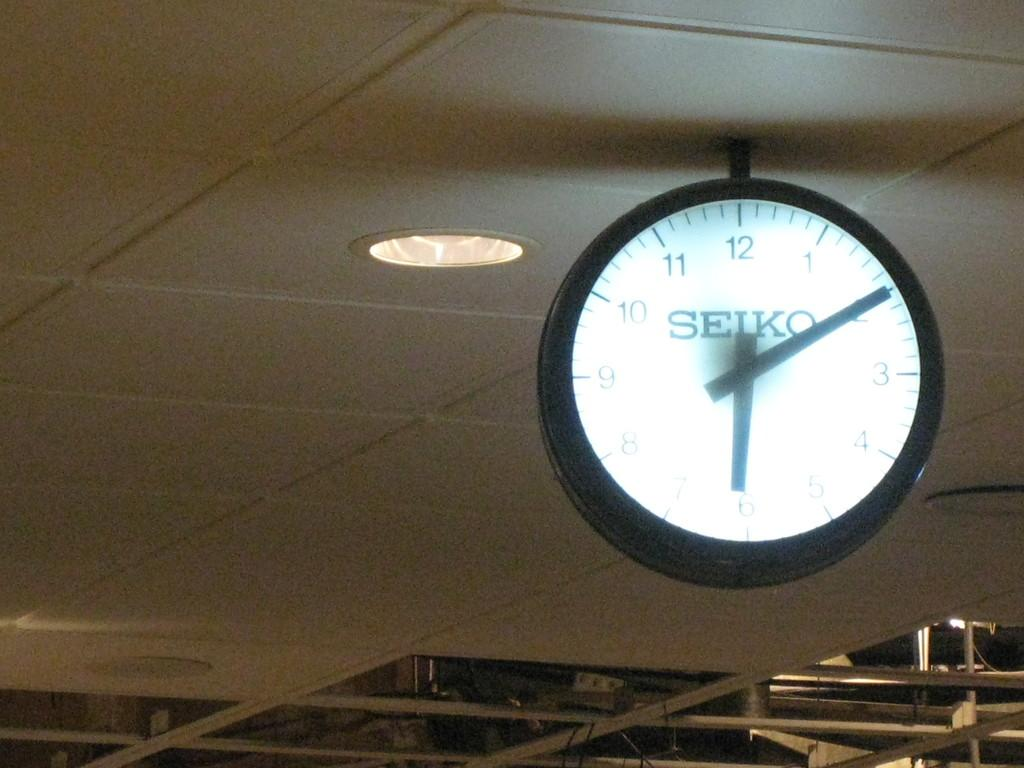<image>
Create a compact narrative representing the image presented. A clock hanging from an indoor ceiling says Seiko on the face. 